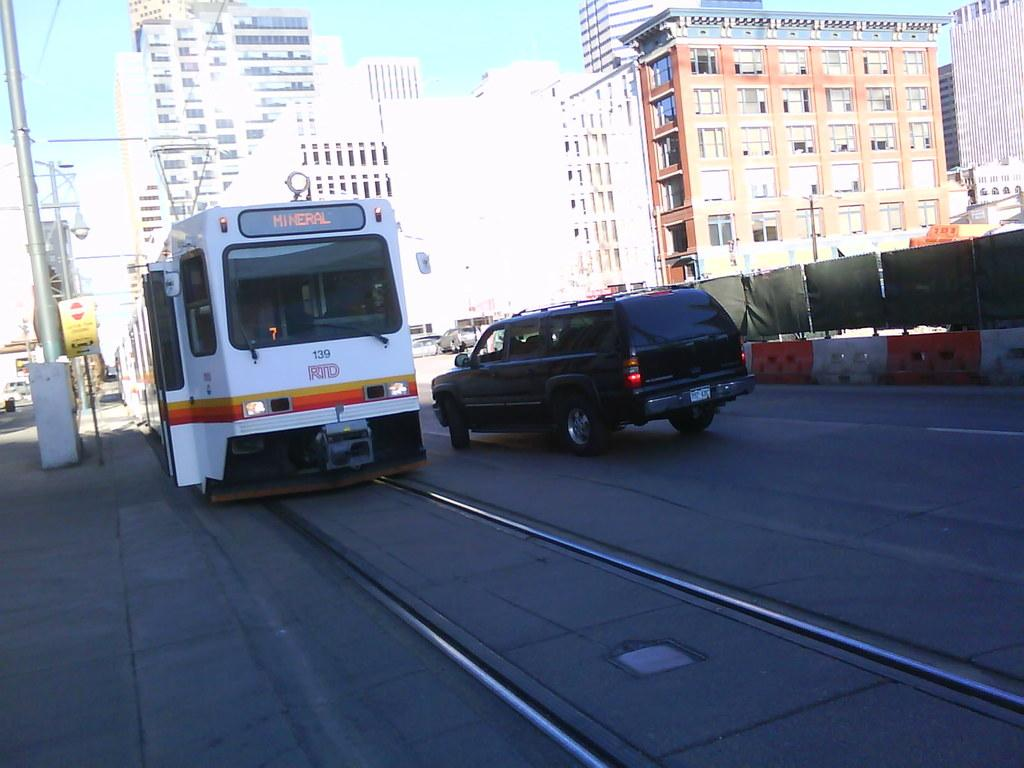What type of vehicle can be seen in the image? There is a tram in the image. What other type of vehicle is present in the image? There is a car in the image. Are the tram and car in motion in the image? Yes, both the tram and car are moving on the road in the image. What structures can be seen in the image? There are barriers, poles, boards, light poles, and buildings in the image. What can be seen in the background of the image? The sky is visible in the background of the image. What type of copper material is used to build the song in the image? There is no copper or song present in the image. How does the sleet affect the tram's movement in the image? There is no sleet present in the image, so it does not affect the tram's movement. 